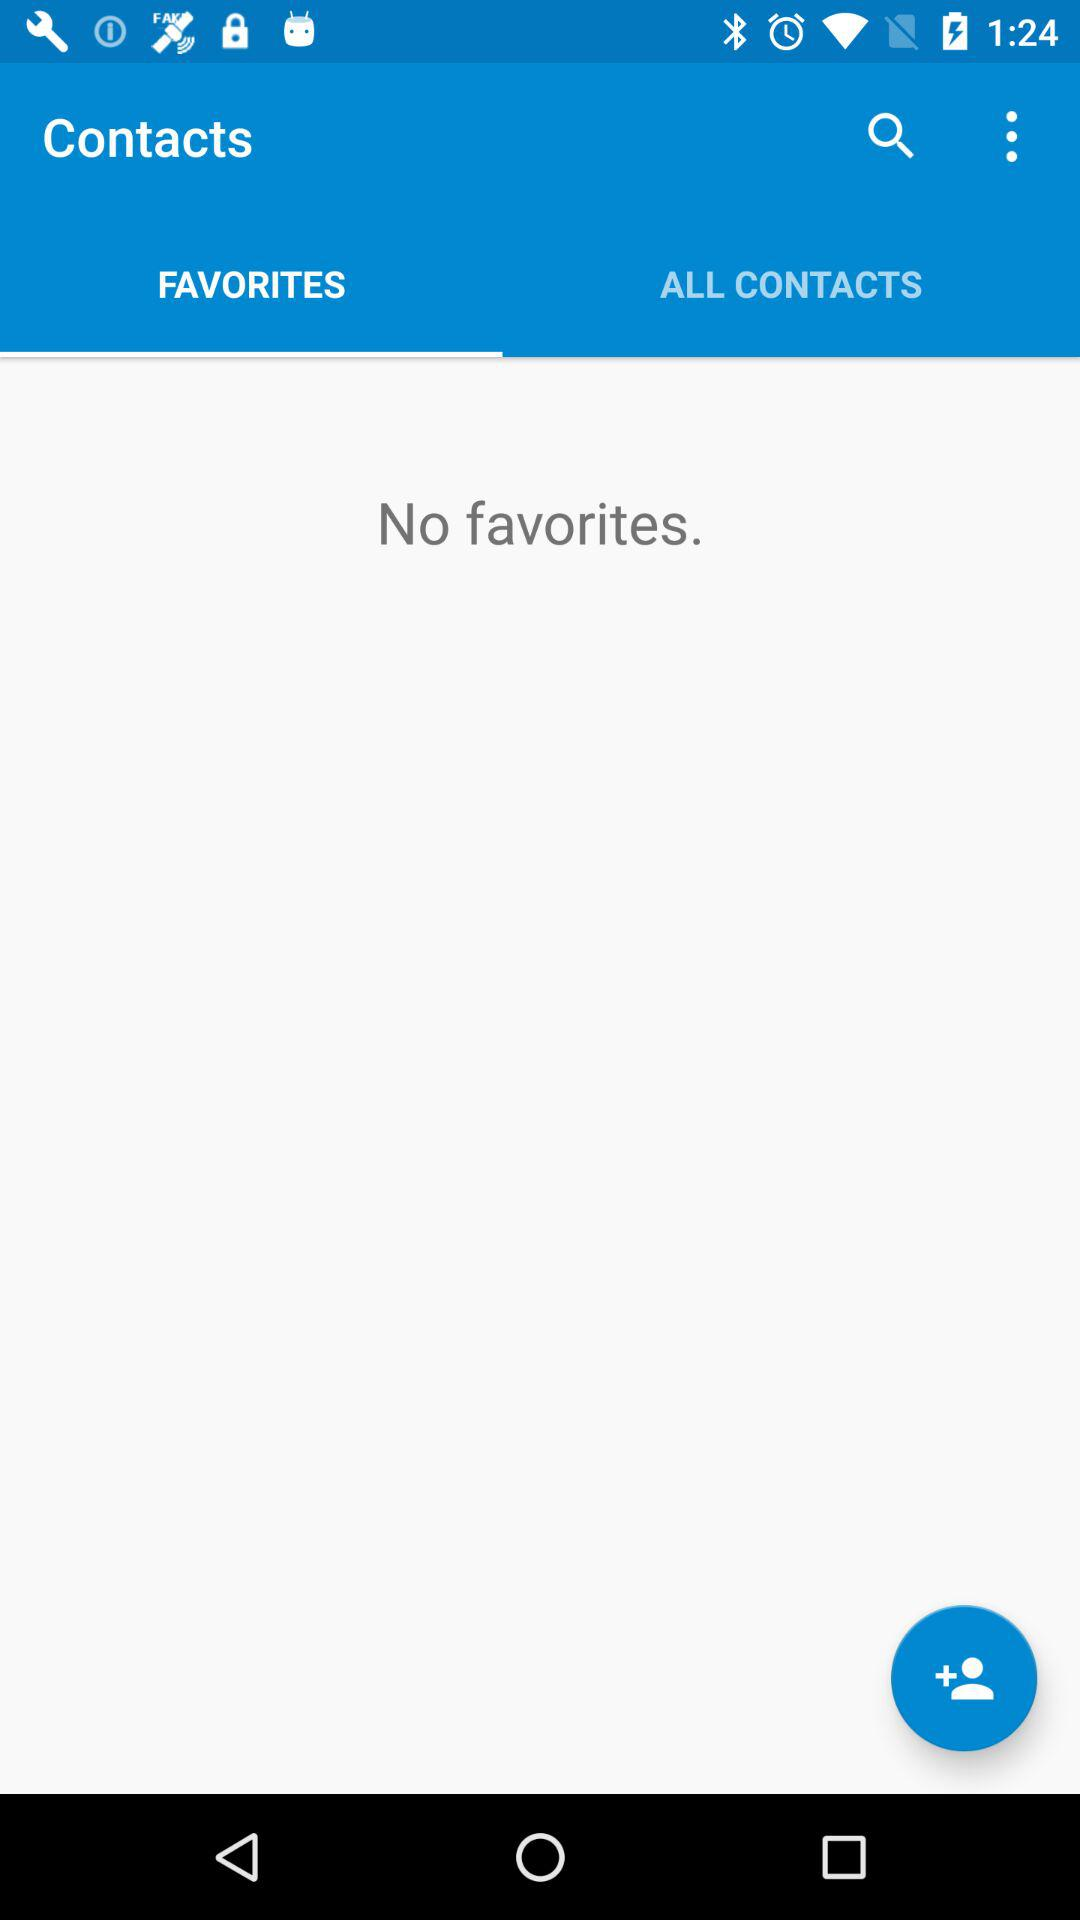How many favorites are there? There are no favorites. 